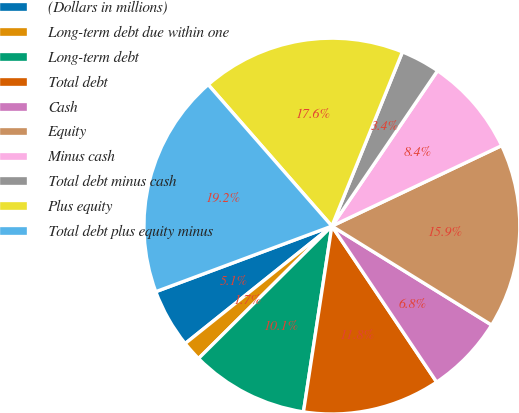Convert chart. <chart><loc_0><loc_0><loc_500><loc_500><pie_chart><fcel>(Dollars in millions)<fcel>Long-term debt due within one<fcel>Long-term debt<fcel>Total debt<fcel>Cash<fcel>Equity<fcel>Minus cash<fcel>Total debt minus cash<fcel>Plus equity<fcel>Total debt plus equity minus<nl><fcel>5.07%<fcel>1.7%<fcel>10.14%<fcel>11.83%<fcel>6.76%<fcel>15.87%<fcel>8.45%<fcel>3.38%<fcel>17.56%<fcel>19.24%<nl></chart> 